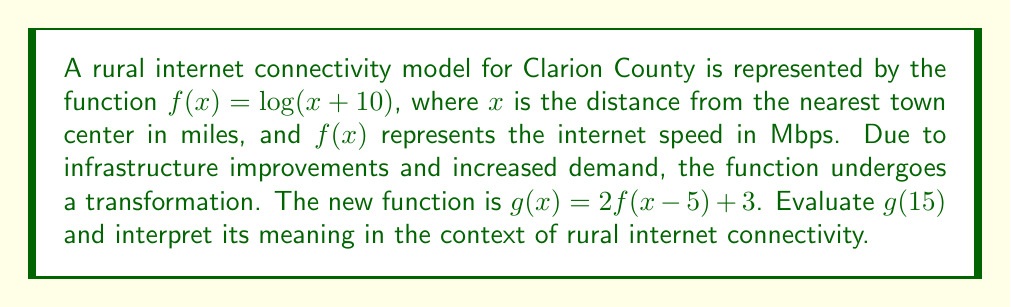What is the answer to this math problem? To solve this problem, we'll follow these steps:

1) First, let's understand the transformation:
   - The original function $f(x)$ is shifted 5 units right: $(x-5)$
   - Then it's vertically stretched by a factor of 2: $2f(x-5)$
   - Finally, it's shifted 3 units up: $2f(x-5) + 3$

2) Now, let's evaluate $g(15)$:
   
   $g(15) = 2f(15-5) + 3$
   
   $= 2f(10) + 3$

3) To calculate $f(10)$, we use the original function:
   
   $f(10) = \log(10+10) = \log(20)$

4) Now we can complete the calculation:
   
   $g(15) = 2\log(20) + 3$
   
   $= 2 * 1.30103 + 3$  (using a calculator or log tables)
   
   $= 2.60206 + 3$
   
   $= 5.60206$

5) Interpretation: At a distance of 15 miles from the nearest town center, the transformed function predicts an internet speed of approximately 5.60 Mbps. This is higher than what the original function would have predicted, reflecting the positive impact of the infrastructure improvements and increased demand on rural internet connectivity in Clarion County.
Answer: $g(15) \approx 5.60$ Mbps 